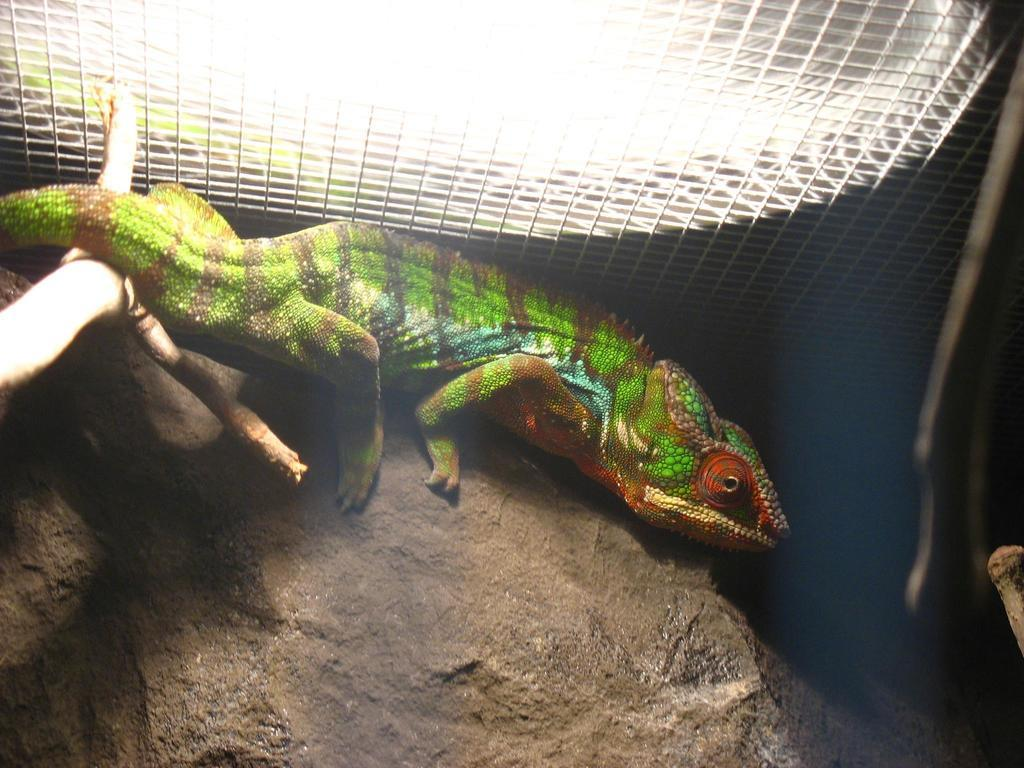What type of animal is in the middle of the image? There is a reptile in the middle of the image. What is located at the bottom of the image? There is a rock at the bottom of the image. What can be seen at the top of the image? There is a net visible at the top of the image. What type of dog is sitting next to the reptile in the image? There is no dog present in the image; it only features a reptile, a rock, and a net. 